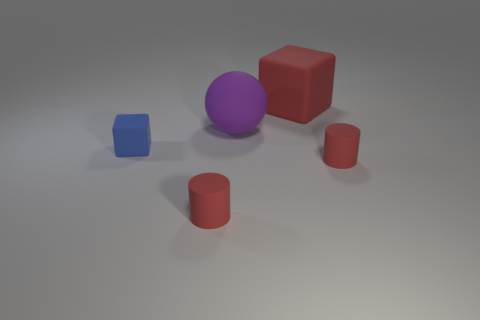Do the block in front of the big red rubber object and the red thing to the left of the big purple rubber object have the same size?
Ensure brevity in your answer.  Yes. Is there a matte cylinder of the same size as the blue matte block?
Give a very brief answer. Yes. There is a red matte object behind the tiny blue rubber block; is it the same shape as the tiny blue rubber object?
Keep it short and to the point. Yes. What is the material of the tiny red object to the left of the matte sphere?
Ensure brevity in your answer.  Rubber. There is a small thing that is right of the matte block that is right of the small blue object; what shape is it?
Give a very brief answer. Cylinder. Is the shape of the small blue rubber thing the same as the small red object that is right of the big red matte thing?
Make the answer very short. No. There is a matte cube on the left side of the purple rubber object; how many rubber cylinders are in front of it?
Offer a terse response. 2. There is a big red object that is the same shape as the blue rubber object; what material is it?
Your answer should be very brief. Rubber. How many green objects are either big rubber things or cylinders?
Make the answer very short. 0. Are there any other things that have the same color as the sphere?
Your response must be concise. No. 